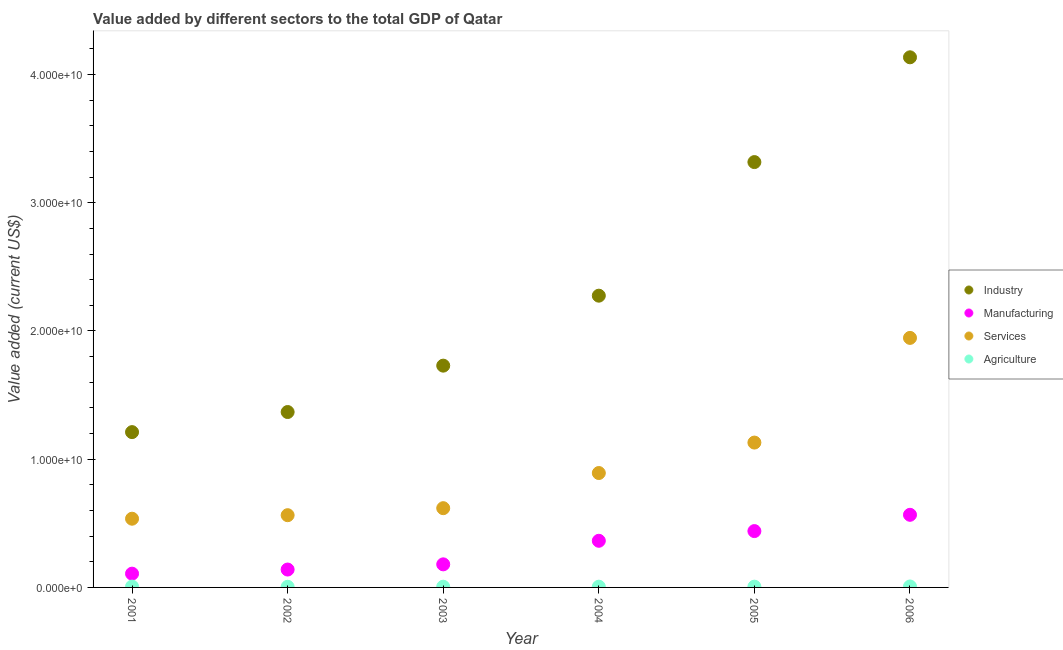How many different coloured dotlines are there?
Your answer should be very brief. 4. What is the value added by industrial sector in 2002?
Your response must be concise. 1.37e+1. Across all years, what is the maximum value added by services sector?
Provide a short and direct response. 1.95e+1. Across all years, what is the minimum value added by agricultural sector?
Offer a very short reply. 4.97e+07. What is the total value added by services sector in the graph?
Provide a succinct answer. 5.69e+1. What is the difference between the value added by agricultural sector in 2005 and that in 2006?
Make the answer very short. -1.48e+07. What is the difference between the value added by industrial sector in 2006 and the value added by agricultural sector in 2004?
Offer a very short reply. 4.13e+1. What is the average value added by services sector per year?
Your answer should be very brief. 9.48e+09. In the year 2001, what is the difference between the value added by agricultural sector and value added by industrial sector?
Provide a succinct answer. -1.20e+1. What is the ratio of the value added by agricultural sector in 2001 to that in 2004?
Make the answer very short. 1.14. Is the value added by industrial sector in 2001 less than that in 2004?
Offer a terse response. Yes. Is the difference between the value added by services sector in 2001 and 2004 greater than the difference between the value added by industrial sector in 2001 and 2004?
Provide a succinct answer. Yes. What is the difference between the highest and the second highest value added by services sector?
Your answer should be very brief. 8.16e+09. What is the difference between the highest and the lowest value added by industrial sector?
Provide a succinct answer. 2.92e+1. In how many years, is the value added by agricultural sector greater than the average value added by agricultural sector taken over all years?
Your answer should be very brief. 2. Does the value added by industrial sector monotonically increase over the years?
Make the answer very short. Yes. Is the value added by manufacturing sector strictly greater than the value added by services sector over the years?
Provide a succinct answer. No. How many dotlines are there?
Ensure brevity in your answer.  4. How many years are there in the graph?
Provide a short and direct response. 6. What is the difference between two consecutive major ticks on the Y-axis?
Give a very brief answer. 1.00e+1. Does the graph contain any zero values?
Ensure brevity in your answer.  No. Where does the legend appear in the graph?
Your response must be concise. Center right. How many legend labels are there?
Your answer should be very brief. 4. How are the legend labels stacked?
Provide a succinct answer. Vertical. What is the title of the graph?
Give a very brief answer. Value added by different sectors to the total GDP of Qatar. What is the label or title of the Y-axis?
Offer a terse response. Value added (current US$). What is the Value added (current US$) in Industry in 2001?
Your answer should be very brief. 1.21e+1. What is the Value added (current US$) of Manufacturing in 2001?
Keep it short and to the point. 1.07e+09. What is the Value added (current US$) in Services in 2001?
Make the answer very short. 5.36e+09. What is the Value added (current US$) in Agriculture in 2001?
Your response must be concise. 6.59e+07. What is the Value added (current US$) in Industry in 2002?
Offer a terse response. 1.37e+1. What is the Value added (current US$) in Manufacturing in 2002?
Your response must be concise. 1.39e+09. What is the Value added (current US$) of Services in 2002?
Provide a succinct answer. 5.63e+09. What is the Value added (current US$) in Agriculture in 2002?
Provide a short and direct response. 4.97e+07. What is the Value added (current US$) in Industry in 2003?
Provide a succinct answer. 1.73e+1. What is the Value added (current US$) in Manufacturing in 2003?
Your response must be concise. 1.80e+09. What is the Value added (current US$) in Services in 2003?
Keep it short and to the point. 6.18e+09. What is the Value added (current US$) in Agriculture in 2003?
Your response must be concise. 5.52e+07. What is the Value added (current US$) in Industry in 2004?
Ensure brevity in your answer.  2.28e+1. What is the Value added (current US$) in Manufacturing in 2004?
Offer a terse response. 3.64e+09. What is the Value added (current US$) of Services in 2004?
Your answer should be compact. 8.92e+09. What is the Value added (current US$) of Agriculture in 2004?
Your answer should be compact. 5.77e+07. What is the Value added (current US$) of Industry in 2005?
Ensure brevity in your answer.  3.32e+1. What is the Value added (current US$) of Manufacturing in 2005?
Offer a very short reply. 4.39e+09. What is the Value added (current US$) in Services in 2005?
Make the answer very short. 1.13e+1. What is the Value added (current US$) of Agriculture in 2005?
Keep it short and to the point. 5.93e+07. What is the Value added (current US$) of Industry in 2006?
Give a very brief answer. 4.13e+1. What is the Value added (current US$) in Manufacturing in 2006?
Provide a succinct answer. 5.66e+09. What is the Value added (current US$) in Services in 2006?
Your response must be concise. 1.95e+1. What is the Value added (current US$) in Agriculture in 2006?
Offer a terse response. 7.42e+07. Across all years, what is the maximum Value added (current US$) of Industry?
Offer a very short reply. 4.13e+1. Across all years, what is the maximum Value added (current US$) of Manufacturing?
Keep it short and to the point. 5.66e+09. Across all years, what is the maximum Value added (current US$) of Services?
Ensure brevity in your answer.  1.95e+1. Across all years, what is the maximum Value added (current US$) of Agriculture?
Provide a succinct answer. 7.42e+07. Across all years, what is the minimum Value added (current US$) of Industry?
Your answer should be compact. 1.21e+1. Across all years, what is the minimum Value added (current US$) of Manufacturing?
Your answer should be compact. 1.07e+09. Across all years, what is the minimum Value added (current US$) in Services?
Your answer should be compact. 5.36e+09. Across all years, what is the minimum Value added (current US$) in Agriculture?
Provide a short and direct response. 4.97e+07. What is the total Value added (current US$) in Industry in the graph?
Keep it short and to the point. 1.40e+11. What is the total Value added (current US$) of Manufacturing in the graph?
Your answer should be very brief. 1.80e+1. What is the total Value added (current US$) in Services in the graph?
Offer a very short reply. 5.69e+1. What is the total Value added (current US$) of Agriculture in the graph?
Your answer should be very brief. 3.62e+08. What is the difference between the Value added (current US$) of Industry in 2001 and that in 2002?
Offer a terse response. -1.57e+09. What is the difference between the Value added (current US$) of Manufacturing in 2001 and that in 2002?
Your response must be concise. -3.21e+08. What is the difference between the Value added (current US$) of Services in 2001 and that in 2002?
Keep it short and to the point. -2.75e+08. What is the difference between the Value added (current US$) of Agriculture in 2001 and that in 2002?
Your answer should be very brief. 1.62e+07. What is the difference between the Value added (current US$) of Industry in 2001 and that in 2003?
Keep it short and to the point. -5.18e+09. What is the difference between the Value added (current US$) in Manufacturing in 2001 and that in 2003?
Offer a very short reply. -7.26e+08. What is the difference between the Value added (current US$) of Services in 2001 and that in 2003?
Keep it short and to the point. -8.22e+08. What is the difference between the Value added (current US$) of Agriculture in 2001 and that in 2003?
Your response must be concise. 1.07e+07. What is the difference between the Value added (current US$) of Industry in 2001 and that in 2004?
Make the answer very short. -1.06e+1. What is the difference between the Value added (current US$) in Manufacturing in 2001 and that in 2004?
Keep it short and to the point. -2.56e+09. What is the difference between the Value added (current US$) of Services in 2001 and that in 2004?
Give a very brief answer. -3.56e+09. What is the difference between the Value added (current US$) in Agriculture in 2001 and that in 2004?
Ensure brevity in your answer.  8.24e+06. What is the difference between the Value added (current US$) in Industry in 2001 and that in 2005?
Offer a terse response. -2.11e+1. What is the difference between the Value added (current US$) in Manufacturing in 2001 and that in 2005?
Make the answer very short. -3.32e+09. What is the difference between the Value added (current US$) of Services in 2001 and that in 2005?
Offer a terse response. -5.94e+09. What is the difference between the Value added (current US$) of Agriculture in 2001 and that in 2005?
Your answer should be compact. 6.59e+06. What is the difference between the Value added (current US$) of Industry in 2001 and that in 2006?
Keep it short and to the point. -2.92e+1. What is the difference between the Value added (current US$) of Manufacturing in 2001 and that in 2006?
Offer a very short reply. -4.59e+09. What is the difference between the Value added (current US$) in Services in 2001 and that in 2006?
Offer a terse response. -1.41e+1. What is the difference between the Value added (current US$) of Agriculture in 2001 and that in 2006?
Provide a succinct answer. -8.24e+06. What is the difference between the Value added (current US$) in Industry in 2002 and that in 2003?
Give a very brief answer. -3.62e+09. What is the difference between the Value added (current US$) in Manufacturing in 2002 and that in 2003?
Your response must be concise. -4.06e+08. What is the difference between the Value added (current US$) in Services in 2002 and that in 2003?
Your answer should be very brief. -5.47e+08. What is the difference between the Value added (current US$) in Agriculture in 2002 and that in 2003?
Make the answer very short. -5.49e+06. What is the difference between the Value added (current US$) in Industry in 2002 and that in 2004?
Offer a terse response. -9.07e+09. What is the difference between the Value added (current US$) in Manufacturing in 2002 and that in 2004?
Your answer should be very brief. -2.24e+09. What is the difference between the Value added (current US$) of Services in 2002 and that in 2004?
Make the answer very short. -3.29e+09. What is the difference between the Value added (current US$) in Agriculture in 2002 and that in 2004?
Your answer should be compact. -7.97e+06. What is the difference between the Value added (current US$) in Industry in 2002 and that in 2005?
Provide a succinct answer. -1.95e+1. What is the difference between the Value added (current US$) of Manufacturing in 2002 and that in 2005?
Make the answer very short. -3.00e+09. What is the difference between the Value added (current US$) in Services in 2002 and that in 2005?
Ensure brevity in your answer.  -5.66e+09. What is the difference between the Value added (current US$) of Agriculture in 2002 and that in 2005?
Provide a short and direct response. -9.62e+06. What is the difference between the Value added (current US$) of Industry in 2002 and that in 2006?
Ensure brevity in your answer.  -2.77e+1. What is the difference between the Value added (current US$) in Manufacturing in 2002 and that in 2006?
Your answer should be very brief. -4.27e+09. What is the difference between the Value added (current US$) of Services in 2002 and that in 2006?
Provide a succinct answer. -1.38e+1. What is the difference between the Value added (current US$) of Agriculture in 2002 and that in 2006?
Provide a succinct answer. -2.45e+07. What is the difference between the Value added (current US$) of Industry in 2003 and that in 2004?
Your answer should be very brief. -5.46e+09. What is the difference between the Value added (current US$) in Manufacturing in 2003 and that in 2004?
Provide a short and direct response. -1.84e+09. What is the difference between the Value added (current US$) of Services in 2003 and that in 2004?
Provide a short and direct response. -2.74e+09. What is the difference between the Value added (current US$) in Agriculture in 2003 and that in 2004?
Give a very brief answer. -2.47e+06. What is the difference between the Value added (current US$) of Industry in 2003 and that in 2005?
Offer a very short reply. -1.59e+1. What is the difference between the Value added (current US$) in Manufacturing in 2003 and that in 2005?
Your response must be concise. -2.59e+09. What is the difference between the Value added (current US$) in Services in 2003 and that in 2005?
Your response must be concise. -5.12e+09. What is the difference between the Value added (current US$) in Agriculture in 2003 and that in 2005?
Your answer should be compact. -4.12e+06. What is the difference between the Value added (current US$) in Industry in 2003 and that in 2006?
Offer a terse response. -2.40e+1. What is the difference between the Value added (current US$) in Manufacturing in 2003 and that in 2006?
Your answer should be very brief. -3.86e+09. What is the difference between the Value added (current US$) of Services in 2003 and that in 2006?
Provide a short and direct response. -1.33e+1. What is the difference between the Value added (current US$) in Agriculture in 2003 and that in 2006?
Offer a very short reply. -1.90e+07. What is the difference between the Value added (current US$) in Industry in 2004 and that in 2005?
Your response must be concise. -1.04e+1. What is the difference between the Value added (current US$) in Manufacturing in 2004 and that in 2005?
Offer a very short reply. -7.56e+08. What is the difference between the Value added (current US$) of Services in 2004 and that in 2005?
Give a very brief answer. -2.38e+09. What is the difference between the Value added (current US$) of Agriculture in 2004 and that in 2005?
Make the answer very short. -1.65e+06. What is the difference between the Value added (current US$) of Industry in 2004 and that in 2006?
Give a very brief answer. -1.86e+1. What is the difference between the Value added (current US$) of Manufacturing in 2004 and that in 2006?
Your answer should be very brief. -2.03e+09. What is the difference between the Value added (current US$) of Services in 2004 and that in 2006?
Provide a succinct answer. -1.05e+1. What is the difference between the Value added (current US$) in Agriculture in 2004 and that in 2006?
Offer a very short reply. -1.65e+07. What is the difference between the Value added (current US$) in Industry in 2005 and that in 2006?
Your answer should be very brief. -8.17e+09. What is the difference between the Value added (current US$) of Manufacturing in 2005 and that in 2006?
Make the answer very short. -1.27e+09. What is the difference between the Value added (current US$) in Services in 2005 and that in 2006?
Ensure brevity in your answer.  -8.16e+09. What is the difference between the Value added (current US$) in Agriculture in 2005 and that in 2006?
Your response must be concise. -1.48e+07. What is the difference between the Value added (current US$) in Industry in 2001 and the Value added (current US$) in Manufacturing in 2002?
Provide a succinct answer. 1.07e+1. What is the difference between the Value added (current US$) in Industry in 2001 and the Value added (current US$) in Services in 2002?
Ensure brevity in your answer.  6.48e+09. What is the difference between the Value added (current US$) in Industry in 2001 and the Value added (current US$) in Agriculture in 2002?
Provide a short and direct response. 1.21e+1. What is the difference between the Value added (current US$) in Manufacturing in 2001 and the Value added (current US$) in Services in 2002?
Your answer should be very brief. -4.56e+09. What is the difference between the Value added (current US$) of Manufacturing in 2001 and the Value added (current US$) of Agriculture in 2002?
Offer a terse response. 1.02e+09. What is the difference between the Value added (current US$) of Services in 2001 and the Value added (current US$) of Agriculture in 2002?
Your answer should be compact. 5.31e+09. What is the difference between the Value added (current US$) in Industry in 2001 and the Value added (current US$) in Manufacturing in 2003?
Offer a terse response. 1.03e+1. What is the difference between the Value added (current US$) in Industry in 2001 and the Value added (current US$) in Services in 2003?
Make the answer very short. 5.93e+09. What is the difference between the Value added (current US$) in Industry in 2001 and the Value added (current US$) in Agriculture in 2003?
Give a very brief answer. 1.21e+1. What is the difference between the Value added (current US$) of Manufacturing in 2001 and the Value added (current US$) of Services in 2003?
Offer a very short reply. -5.11e+09. What is the difference between the Value added (current US$) in Manufacturing in 2001 and the Value added (current US$) in Agriculture in 2003?
Offer a very short reply. 1.02e+09. What is the difference between the Value added (current US$) of Services in 2001 and the Value added (current US$) of Agriculture in 2003?
Ensure brevity in your answer.  5.30e+09. What is the difference between the Value added (current US$) in Industry in 2001 and the Value added (current US$) in Manufacturing in 2004?
Give a very brief answer. 8.48e+09. What is the difference between the Value added (current US$) in Industry in 2001 and the Value added (current US$) in Services in 2004?
Offer a very short reply. 3.19e+09. What is the difference between the Value added (current US$) of Industry in 2001 and the Value added (current US$) of Agriculture in 2004?
Offer a terse response. 1.21e+1. What is the difference between the Value added (current US$) in Manufacturing in 2001 and the Value added (current US$) in Services in 2004?
Offer a very short reply. -7.85e+09. What is the difference between the Value added (current US$) of Manufacturing in 2001 and the Value added (current US$) of Agriculture in 2004?
Provide a succinct answer. 1.02e+09. What is the difference between the Value added (current US$) in Services in 2001 and the Value added (current US$) in Agriculture in 2004?
Your answer should be very brief. 5.30e+09. What is the difference between the Value added (current US$) of Industry in 2001 and the Value added (current US$) of Manufacturing in 2005?
Ensure brevity in your answer.  7.72e+09. What is the difference between the Value added (current US$) in Industry in 2001 and the Value added (current US$) in Services in 2005?
Ensure brevity in your answer.  8.16e+08. What is the difference between the Value added (current US$) of Industry in 2001 and the Value added (current US$) of Agriculture in 2005?
Your answer should be compact. 1.21e+1. What is the difference between the Value added (current US$) in Manufacturing in 2001 and the Value added (current US$) in Services in 2005?
Offer a terse response. -1.02e+1. What is the difference between the Value added (current US$) in Manufacturing in 2001 and the Value added (current US$) in Agriculture in 2005?
Your answer should be compact. 1.01e+09. What is the difference between the Value added (current US$) of Services in 2001 and the Value added (current US$) of Agriculture in 2005?
Provide a short and direct response. 5.30e+09. What is the difference between the Value added (current US$) of Industry in 2001 and the Value added (current US$) of Manufacturing in 2006?
Your response must be concise. 6.45e+09. What is the difference between the Value added (current US$) of Industry in 2001 and the Value added (current US$) of Services in 2006?
Give a very brief answer. -7.35e+09. What is the difference between the Value added (current US$) in Industry in 2001 and the Value added (current US$) in Agriculture in 2006?
Give a very brief answer. 1.20e+1. What is the difference between the Value added (current US$) of Manufacturing in 2001 and the Value added (current US$) of Services in 2006?
Offer a terse response. -1.84e+1. What is the difference between the Value added (current US$) of Manufacturing in 2001 and the Value added (current US$) of Agriculture in 2006?
Give a very brief answer. 1.00e+09. What is the difference between the Value added (current US$) in Services in 2001 and the Value added (current US$) in Agriculture in 2006?
Ensure brevity in your answer.  5.29e+09. What is the difference between the Value added (current US$) of Industry in 2002 and the Value added (current US$) of Manufacturing in 2003?
Give a very brief answer. 1.19e+1. What is the difference between the Value added (current US$) in Industry in 2002 and the Value added (current US$) in Services in 2003?
Your answer should be compact. 7.50e+09. What is the difference between the Value added (current US$) of Industry in 2002 and the Value added (current US$) of Agriculture in 2003?
Give a very brief answer. 1.36e+1. What is the difference between the Value added (current US$) in Manufacturing in 2002 and the Value added (current US$) in Services in 2003?
Provide a succinct answer. -4.79e+09. What is the difference between the Value added (current US$) of Manufacturing in 2002 and the Value added (current US$) of Agriculture in 2003?
Make the answer very short. 1.34e+09. What is the difference between the Value added (current US$) in Services in 2002 and the Value added (current US$) in Agriculture in 2003?
Make the answer very short. 5.58e+09. What is the difference between the Value added (current US$) of Industry in 2002 and the Value added (current US$) of Manufacturing in 2004?
Ensure brevity in your answer.  1.00e+1. What is the difference between the Value added (current US$) in Industry in 2002 and the Value added (current US$) in Services in 2004?
Give a very brief answer. 4.76e+09. What is the difference between the Value added (current US$) of Industry in 2002 and the Value added (current US$) of Agriculture in 2004?
Your answer should be very brief. 1.36e+1. What is the difference between the Value added (current US$) of Manufacturing in 2002 and the Value added (current US$) of Services in 2004?
Your answer should be compact. -7.53e+09. What is the difference between the Value added (current US$) of Manufacturing in 2002 and the Value added (current US$) of Agriculture in 2004?
Your answer should be very brief. 1.34e+09. What is the difference between the Value added (current US$) in Services in 2002 and the Value added (current US$) in Agriculture in 2004?
Your answer should be compact. 5.58e+09. What is the difference between the Value added (current US$) in Industry in 2002 and the Value added (current US$) in Manufacturing in 2005?
Your answer should be very brief. 9.29e+09. What is the difference between the Value added (current US$) of Industry in 2002 and the Value added (current US$) of Services in 2005?
Offer a terse response. 2.38e+09. What is the difference between the Value added (current US$) in Industry in 2002 and the Value added (current US$) in Agriculture in 2005?
Provide a short and direct response. 1.36e+1. What is the difference between the Value added (current US$) in Manufacturing in 2002 and the Value added (current US$) in Services in 2005?
Offer a terse response. -9.90e+09. What is the difference between the Value added (current US$) of Manufacturing in 2002 and the Value added (current US$) of Agriculture in 2005?
Offer a very short reply. 1.34e+09. What is the difference between the Value added (current US$) in Services in 2002 and the Value added (current US$) in Agriculture in 2005?
Provide a short and direct response. 5.57e+09. What is the difference between the Value added (current US$) in Industry in 2002 and the Value added (current US$) in Manufacturing in 2006?
Your answer should be very brief. 8.02e+09. What is the difference between the Value added (current US$) of Industry in 2002 and the Value added (current US$) of Services in 2006?
Offer a very short reply. -5.78e+09. What is the difference between the Value added (current US$) of Industry in 2002 and the Value added (current US$) of Agriculture in 2006?
Offer a very short reply. 1.36e+1. What is the difference between the Value added (current US$) of Manufacturing in 2002 and the Value added (current US$) of Services in 2006?
Your response must be concise. -1.81e+1. What is the difference between the Value added (current US$) of Manufacturing in 2002 and the Value added (current US$) of Agriculture in 2006?
Your response must be concise. 1.32e+09. What is the difference between the Value added (current US$) in Services in 2002 and the Value added (current US$) in Agriculture in 2006?
Your answer should be very brief. 5.56e+09. What is the difference between the Value added (current US$) in Industry in 2003 and the Value added (current US$) in Manufacturing in 2004?
Your answer should be compact. 1.37e+1. What is the difference between the Value added (current US$) of Industry in 2003 and the Value added (current US$) of Services in 2004?
Your response must be concise. 8.38e+09. What is the difference between the Value added (current US$) of Industry in 2003 and the Value added (current US$) of Agriculture in 2004?
Your answer should be very brief. 1.72e+1. What is the difference between the Value added (current US$) of Manufacturing in 2003 and the Value added (current US$) of Services in 2004?
Provide a succinct answer. -7.12e+09. What is the difference between the Value added (current US$) of Manufacturing in 2003 and the Value added (current US$) of Agriculture in 2004?
Provide a short and direct response. 1.74e+09. What is the difference between the Value added (current US$) of Services in 2003 and the Value added (current US$) of Agriculture in 2004?
Make the answer very short. 6.12e+09. What is the difference between the Value added (current US$) of Industry in 2003 and the Value added (current US$) of Manufacturing in 2005?
Your response must be concise. 1.29e+1. What is the difference between the Value added (current US$) of Industry in 2003 and the Value added (current US$) of Services in 2005?
Your answer should be compact. 6.00e+09. What is the difference between the Value added (current US$) in Industry in 2003 and the Value added (current US$) in Agriculture in 2005?
Offer a very short reply. 1.72e+1. What is the difference between the Value added (current US$) of Manufacturing in 2003 and the Value added (current US$) of Services in 2005?
Make the answer very short. -9.50e+09. What is the difference between the Value added (current US$) of Manufacturing in 2003 and the Value added (current US$) of Agriculture in 2005?
Your response must be concise. 1.74e+09. What is the difference between the Value added (current US$) in Services in 2003 and the Value added (current US$) in Agriculture in 2005?
Ensure brevity in your answer.  6.12e+09. What is the difference between the Value added (current US$) of Industry in 2003 and the Value added (current US$) of Manufacturing in 2006?
Ensure brevity in your answer.  1.16e+1. What is the difference between the Value added (current US$) of Industry in 2003 and the Value added (current US$) of Services in 2006?
Ensure brevity in your answer.  -2.16e+09. What is the difference between the Value added (current US$) of Industry in 2003 and the Value added (current US$) of Agriculture in 2006?
Provide a short and direct response. 1.72e+1. What is the difference between the Value added (current US$) of Manufacturing in 2003 and the Value added (current US$) of Services in 2006?
Ensure brevity in your answer.  -1.77e+1. What is the difference between the Value added (current US$) of Manufacturing in 2003 and the Value added (current US$) of Agriculture in 2006?
Your answer should be very brief. 1.73e+09. What is the difference between the Value added (current US$) of Services in 2003 and the Value added (current US$) of Agriculture in 2006?
Provide a short and direct response. 6.11e+09. What is the difference between the Value added (current US$) in Industry in 2004 and the Value added (current US$) in Manufacturing in 2005?
Offer a terse response. 1.84e+1. What is the difference between the Value added (current US$) of Industry in 2004 and the Value added (current US$) of Services in 2005?
Your response must be concise. 1.15e+1. What is the difference between the Value added (current US$) of Industry in 2004 and the Value added (current US$) of Agriculture in 2005?
Offer a very short reply. 2.27e+1. What is the difference between the Value added (current US$) in Manufacturing in 2004 and the Value added (current US$) in Services in 2005?
Keep it short and to the point. -7.66e+09. What is the difference between the Value added (current US$) of Manufacturing in 2004 and the Value added (current US$) of Agriculture in 2005?
Offer a very short reply. 3.58e+09. What is the difference between the Value added (current US$) of Services in 2004 and the Value added (current US$) of Agriculture in 2005?
Give a very brief answer. 8.86e+09. What is the difference between the Value added (current US$) of Industry in 2004 and the Value added (current US$) of Manufacturing in 2006?
Your answer should be compact. 1.71e+1. What is the difference between the Value added (current US$) in Industry in 2004 and the Value added (current US$) in Services in 2006?
Ensure brevity in your answer.  3.29e+09. What is the difference between the Value added (current US$) in Industry in 2004 and the Value added (current US$) in Agriculture in 2006?
Offer a terse response. 2.27e+1. What is the difference between the Value added (current US$) of Manufacturing in 2004 and the Value added (current US$) of Services in 2006?
Offer a terse response. -1.58e+1. What is the difference between the Value added (current US$) in Manufacturing in 2004 and the Value added (current US$) in Agriculture in 2006?
Your answer should be compact. 3.56e+09. What is the difference between the Value added (current US$) of Services in 2004 and the Value added (current US$) of Agriculture in 2006?
Offer a very short reply. 8.85e+09. What is the difference between the Value added (current US$) in Industry in 2005 and the Value added (current US$) in Manufacturing in 2006?
Offer a very short reply. 2.75e+1. What is the difference between the Value added (current US$) of Industry in 2005 and the Value added (current US$) of Services in 2006?
Ensure brevity in your answer.  1.37e+1. What is the difference between the Value added (current US$) in Industry in 2005 and the Value added (current US$) in Agriculture in 2006?
Make the answer very short. 3.31e+1. What is the difference between the Value added (current US$) of Manufacturing in 2005 and the Value added (current US$) of Services in 2006?
Your answer should be compact. -1.51e+1. What is the difference between the Value added (current US$) of Manufacturing in 2005 and the Value added (current US$) of Agriculture in 2006?
Your answer should be very brief. 4.32e+09. What is the difference between the Value added (current US$) of Services in 2005 and the Value added (current US$) of Agriculture in 2006?
Make the answer very short. 1.12e+1. What is the average Value added (current US$) of Industry per year?
Ensure brevity in your answer.  2.34e+1. What is the average Value added (current US$) of Manufacturing per year?
Provide a short and direct response. 2.99e+09. What is the average Value added (current US$) of Services per year?
Your answer should be compact. 9.48e+09. What is the average Value added (current US$) of Agriculture per year?
Provide a succinct answer. 6.03e+07. In the year 2001, what is the difference between the Value added (current US$) in Industry and Value added (current US$) in Manufacturing?
Offer a terse response. 1.10e+1. In the year 2001, what is the difference between the Value added (current US$) in Industry and Value added (current US$) in Services?
Ensure brevity in your answer.  6.75e+09. In the year 2001, what is the difference between the Value added (current US$) in Industry and Value added (current US$) in Agriculture?
Provide a succinct answer. 1.20e+1. In the year 2001, what is the difference between the Value added (current US$) in Manufacturing and Value added (current US$) in Services?
Provide a succinct answer. -4.29e+09. In the year 2001, what is the difference between the Value added (current US$) in Manufacturing and Value added (current US$) in Agriculture?
Ensure brevity in your answer.  1.01e+09. In the year 2001, what is the difference between the Value added (current US$) of Services and Value added (current US$) of Agriculture?
Offer a terse response. 5.29e+09. In the year 2002, what is the difference between the Value added (current US$) of Industry and Value added (current US$) of Manufacturing?
Offer a very short reply. 1.23e+1. In the year 2002, what is the difference between the Value added (current US$) in Industry and Value added (current US$) in Services?
Keep it short and to the point. 8.05e+09. In the year 2002, what is the difference between the Value added (current US$) of Industry and Value added (current US$) of Agriculture?
Provide a succinct answer. 1.36e+1. In the year 2002, what is the difference between the Value added (current US$) of Manufacturing and Value added (current US$) of Services?
Your response must be concise. -4.24e+09. In the year 2002, what is the difference between the Value added (current US$) of Manufacturing and Value added (current US$) of Agriculture?
Provide a succinct answer. 1.34e+09. In the year 2002, what is the difference between the Value added (current US$) in Services and Value added (current US$) in Agriculture?
Offer a very short reply. 5.58e+09. In the year 2003, what is the difference between the Value added (current US$) of Industry and Value added (current US$) of Manufacturing?
Your answer should be very brief. 1.55e+1. In the year 2003, what is the difference between the Value added (current US$) in Industry and Value added (current US$) in Services?
Your answer should be very brief. 1.11e+1. In the year 2003, what is the difference between the Value added (current US$) of Industry and Value added (current US$) of Agriculture?
Your answer should be very brief. 1.72e+1. In the year 2003, what is the difference between the Value added (current US$) in Manufacturing and Value added (current US$) in Services?
Give a very brief answer. -4.38e+09. In the year 2003, what is the difference between the Value added (current US$) in Manufacturing and Value added (current US$) in Agriculture?
Make the answer very short. 1.75e+09. In the year 2003, what is the difference between the Value added (current US$) of Services and Value added (current US$) of Agriculture?
Ensure brevity in your answer.  6.13e+09. In the year 2004, what is the difference between the Value added (current US$) in Industry and Value added (current US$) in Manufacturing?
Make the answer very short. 1.91e+1. In the year 2004, what is the difference between the Value added (current US$) of Industry and Value added (current US$) of Services?
Ensure brevity in your answer.  1.38e+1. In the year 2004, what is the difference between the Value added (current US$) of Industry and Value added (current US$) of Agriculture?
Keep it short and to the point. 2.27e+1. In the year 2004, what is the difference between the Value added (current US$) in Manufacturing and Value added (current US$) in Services?
Your answer should be compact. -5.28e+09. In the year 2004, what is the difference between the Value added (current US$) in Manufacturing and Value added (current US$) in Agriculture?
Offer a very short reply. 3.58e+09. In the year 2004, what is the difference between the Value added (current US$) in Services and Value added (current US$) in Agriculture?
Provide a succinct answer. 8.86e+09. In the year 2005, what is the difference between the Value added (current US$) in Industry and Value added (current US$) in Manufacturing?
Provide a short and direct response. 2.88e+1. In the year 2005, what is the difference between the Value added (current US$) of Industry and Value added (current US$) of Services?
Your answer should be very brief. 2.19e+1. In the year 2005, what is the difference between the Value added (current US$) in Industry and Value added (current US$) in Agriculture?
Your response must be concise. 3.31e+1. In the year 2005, what is the difference between the Value added (current US$) of Manufacturing and Value added (current US$) of Services?
Keep it short and to the point. -6.90e+09. In the year 2005, what is the difference between the Value added (current US$) of Manufacturing and Value added (current US$) of Agriculture?
Your answer should be compact. 4.33e+09. In the year 2005, what is the difference between the Value added (current US$) of Services and Value added (current US$) of Agriculture?
Keep it short and to the point. 1.12e+1. In the year 2006, what is the difference between the Value added (current US$) of Industry and Value added (current US$) of Manufacturing?
Offer a very short reply. 3.57e+1. In the year 2006, what is the difference between the Value added (current US$) of Industry and Value added (current US$) of Services?
Keep it short and to the point. 2.19e+1. In the year 2006, what is the difference between the Value added (current US$) of Industry and Value added (current US$) of Agriculture?
Provide a short and direct response. 4.13e+1. In the year 2006, what is the difference between the Value added (current US$) in Manufacturing and Value added (current US$) in Services?
Your answer should be very brief. -1.38e+1. In the year 2006, what is the difference between the Value added (current US$) of Manufacturing and Value added (current US$) of Agriculture?
Give a very brief answer. 5.59e+09. In the year 2006, what is the difference between the Value added (current US$) of Services and Value added (current US$) of Agriculture?
Offer a terse response. 1.94e+1. What is the ratio of the Value added (current US$) in Industry in 2001 to that in 2002?
Ensure brevity in your answer.  0.89. What is the ratio of the Value added (current US$) of Manufacturing in 2001 to that in 2002?
Make the answer very short. 0.77. What is the ratio of the Value added (current US$) in Services in 2001 to that in 2002?
Your answer should be very brief. 0.95. What is the ratio of the Value added (current US$) of Agriculture in 2001 to that in 2002?
Offer a very short reply. 1.33. What is the ratio of the Value added (current US$) in Industry in 2001 to that in 2003?
Make the answer very short. 0.7. What is the ratio of the Value added (current US$) of Manufacturing in 2001 to that in 2003?
Your answer should be very brief. 0.6. What is the ratio of the Value added (current US$) in Services in 2001 to that in 2003?
Give a very brief answer. 0.87. What is the ratio of the Value added (current US$) in Agriculture in 2001 to that in 2003?
Your answer should be compact. 1.19. What is the ratio of the Value added (current US$) of Industry in 2001 to that in 2004?
Give a very brief answer. 0.53. What is the ratio of the Value added (current US$) in Manufacturing in 2001 to that in 2004?
Make the answer very short. 0.3. What is the ratio of the Value added (current US$) in Services in 2001 to that in 2004?
Your answer should be compact. 0.6. What is the ratio of the Value added (current US$) of Agriculture in 2001 to that in 2004?
Your answer should be compact. 1.14. What is the ratio of the Value added (current US$) in Industry in 2001 to that in 2005?
Give a very brief answer. 0.37. What is the ratio of the Value added (current US$) of Manufacturing in 2001 to that in 2005?
Your answer should be very brief. 0.24. What is the ratio of the Value added (current US$) in Services in 2001 to that in 2005?
Give a very brief answer. 0.47. What is the ratio of the Value added (current US$) in Agriculture in 2001 to that in 2005?
Ensure brevity in your answer.  1.11. What is the ratio of the Value added (current US$) of Industry in 2001 to that in 2006?
Make the answer very short. 0.29. What is the ratio of the Value added (current US$) in Manufacturing in 2001 to that in 2006?
Provide a succinct answer. 0.19. What is the ratio of the Value added (current US$) of Services in 2001 to that in 2006?
Offer a terse response. 0.28. What is the ratio of the Value added (current US$) of Industry in 2002 to that in 2003?
Your response must be concise. 0.79. What is the ratio of the Value added (current US$) of Manufacturing in 2002 to that in 2003?
Offer a terse response. 0.77. What is the ratio of the Value added (current US$) of Services in 2002 to that in 2003?
Your response must be concise. 0.91. What is the ratio of the Value added (current US$) of Agriculture in 2002 to that in 2003?
Give a very brief answer. 0.9. What is the ratio of the Value added (current US$) of Industry in 2002 to that in 2004?
Provide a short and direct response. 0.6. What is the ratio of the Value added (current US$) of Manufacturing in 2002 to that in 2004?
Keep it short and to the point. 0.38. What is the ratio of the Value added (current US$) in Services in 2002 to that in 2004?
Your response must be concise. 0.63. What is the ratio of the Value added (current US$) in Agriculture in 2002 to that in 2004?
Give a very brief answer. 0.86. What is the ratio of the Value added (current US$) of Industry in 2002 to that in 2005?
Provide a short and direct response. 0.41. What is the ratio of the Value added (current US$) in Manufacturing in 2002 to that in 2005?
Ensure brevity in your answer.  0.32. What is the ratio of the Value added (current US$) in Services in 2002 to that in 2005?
Keep it short and to the point. 0.5. What is the ratio of the Value added (current US$) of Agriculture in 2002 to that in 2005?
Your answer should be compact. 0.84. What is the ratio of the Value added (current US$) of Industry in 2002 to that in 2006?
Make the answer very short. 0.33. What is the ratio of the Value added (current US$) of Manufacturing in 2002 to that in 2006?
Offer a very short reply. 0.25. What is the ratio of the Value added (current US$) in Services in 2002 to that in 2006?
Keep it short and to the point. 0.29. What is the ratio of the Value added (current US$) of Agriculture in 2002 to that in 2006?
Provide a succinct answer. 0.67. What is the ratio of the Value added (current US$) in Industry in 2003 to that in 2004?
Provide a short and direct response. 0.76. What is the ratio of the Value added (current US$) in Manufacturing in 2003 to that in 2004?
Keep it short and to the point. 0.49. What is the ratio of the Value added (current US$) in Services in 2003 to that in 2004?
Provide a short and direct response. 0.69. What is the ratio of the Value added (current US$) of Agriculture in 2003 to that in 2004?
Offer a very short reply. 0.96. What is the ratio of the Value added (current US$) of Industry in 2003 to that in 2005?
Your answer should be compact. 0.52. What is the ratio of the Value added (current US$) in Manufacturing in 2003 to that in 2005?
Provide a short and direct response. 0.41. What is the ratio of the Value added (current US$) in Services in 2003 to that in 2005?
Your answer should be compact. 0.55. What is the ratio of the Value added (current US$) of Agriculture in 2003 to that in 2005?
Offer a very short reply. 0.93. What is the ratio of the Value added (current US$) of Industry in 2003 to that in 2006?
Provide a short and direct response. 0.42. What is the ratio of the Value added (current US$) of Manufacturing in 2003 to that in 2006?
Your answer should be compact. 0.32. What is the ratio of the Value added (current US$) of Services in 2003 to that in 2006?
Your answer should be compact. 0.32. What is the ratio of the Value added (current US$) of Agriculture in 2003 to that in 2006?
Your answer should be compact. 0.74. What is the ratio of the Value added (current US$) in Industry in 2004 to that in 2005?
Your response must be concise. 0.69. What is the ratio of the Value added (current US$) of Manufacturing in 2004 to that in 2005?
Offer a terse response. 0.83. What is the ratio of the Value added (current US$) in Services in 2004 to that in 2005?
Your answer should be compact. 0.79. What is the ratio of the Value added (current US$) in Agriculture in 2004 to that in 2005?
Provide a succinct answer. 0.97. What is the ratio of the Value added (current US$) of Industry in 2004 to that in 2006?
Provide a short and direct response. 0.55. What is the ratio of the Value added (current US$) of Manufacturing in 2004 to that in 2006?
Give a very brief answer. 0.64. What is the ratio of the Value added (current US$) in Services in 2004 to that in 2006?
Your response must be concise. 0.46. What is the ratio of the Value added (current US$) in Agriculture in 2004 to that in 2006?
Your answer should be compact. 0.78. What is the ratio of the Value added (current US$) in Industry in 2005 to that in 2006?
Offer a very short reply. 0.8. What is the ratio of the Value added (current US$) in Manufacturing in 2005 to that in 2006?
Provide a short and direct response. 0.78. What is the ratio of the Value added (current US$) of Services in 2005 to that in 2006?
Your answer should be compact. 0.58. What is the difference between the highest and the second highest Value added (current US$) of Industry?
Your response must be concise. 8.17e+09. What is the difference between the highest and the second highest Value added (current US$) in Manufacturing?
Your response must be concise. 1.27e+09. What is the difference between the highest and the second highest Value added (current US$) in Services?
Provide a succinct answer. 8.16e+09. What is the difference between the highest and the second highest Value added (current US$) of Agriculture?
Offer a terse response. 8.24e+06. What is the difference between the highest and the lowest Value added (current US$) of Industry?
Provide a succinct answer. 2.92e+1. What is the difference between the highest and the lowest Value added (current US$) in Manufacturing?
Your answer should be very brief. 4.59e+09. What is the difference between the highest and the lowest Value added (current US$) of Services?
Provide a short and direct response. 1.41e+1. What is the difference between the highest and the lowest Value added (current US$) in Agriculture?
Provide a short and direct response. 2.45e+07. 